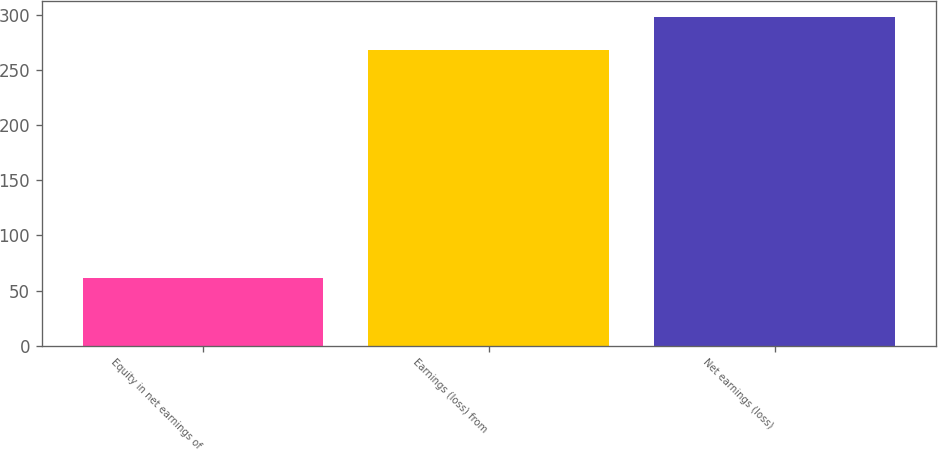<chart> <loc_0><loc_0><loc_500><loc_500><bar_chart><fcel>Equity in net earnings of<fcel>Earnings (loss) from<fcel>Net earnings (loss)<nl><fcel>61<fcel>268<fcel>298.1<nl></chart> 